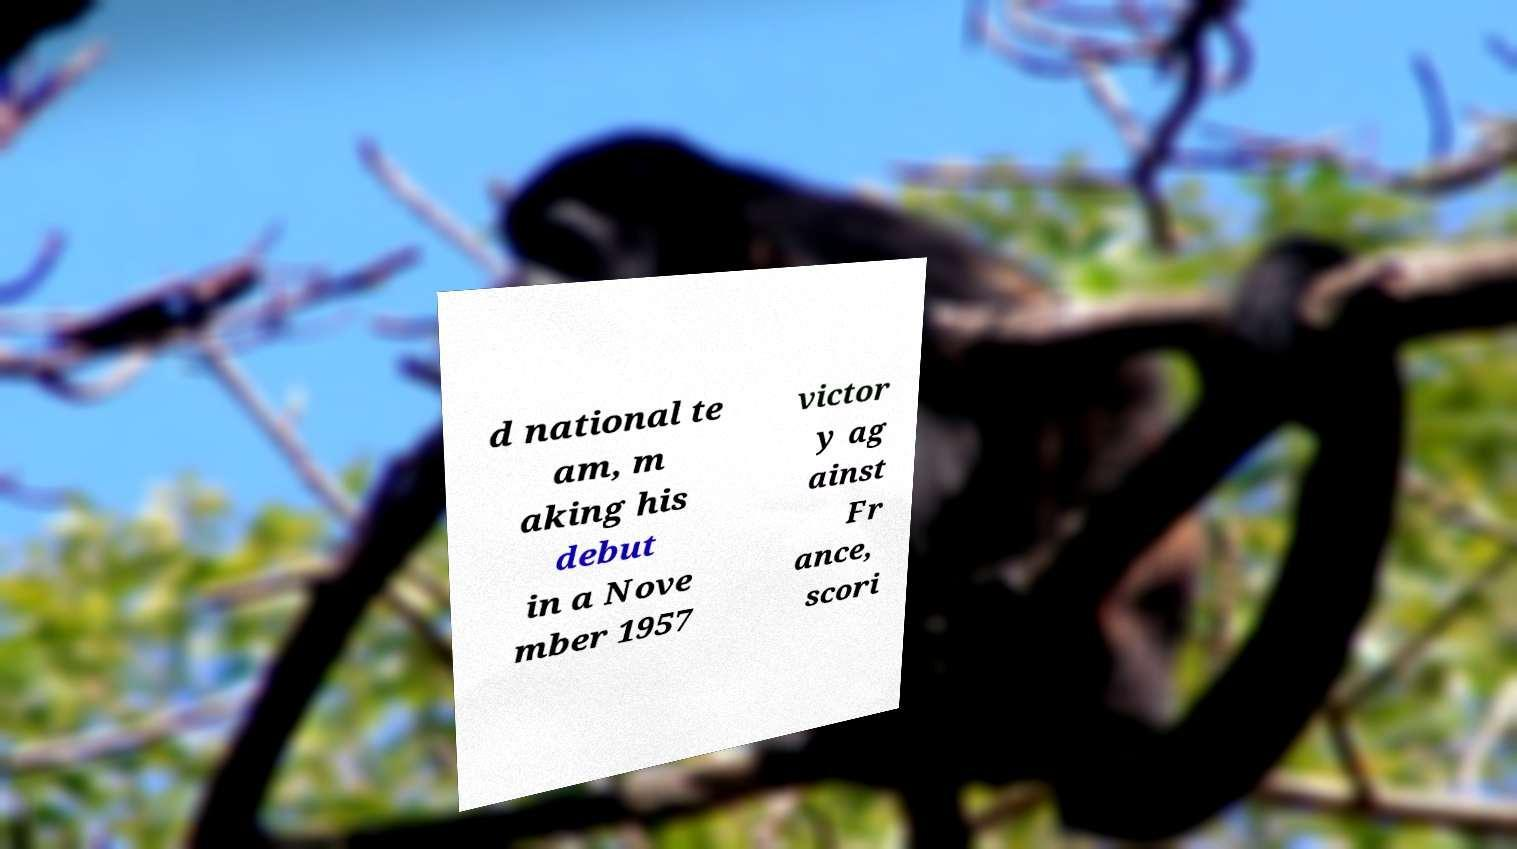Can you read and provide the text displayed in the image?This photo seems to have some interesting text. Can you extract and type it out for me? d national te am, m aking his debut in a Nove mber 1957 victor y ag ainst Fr ance, scori 